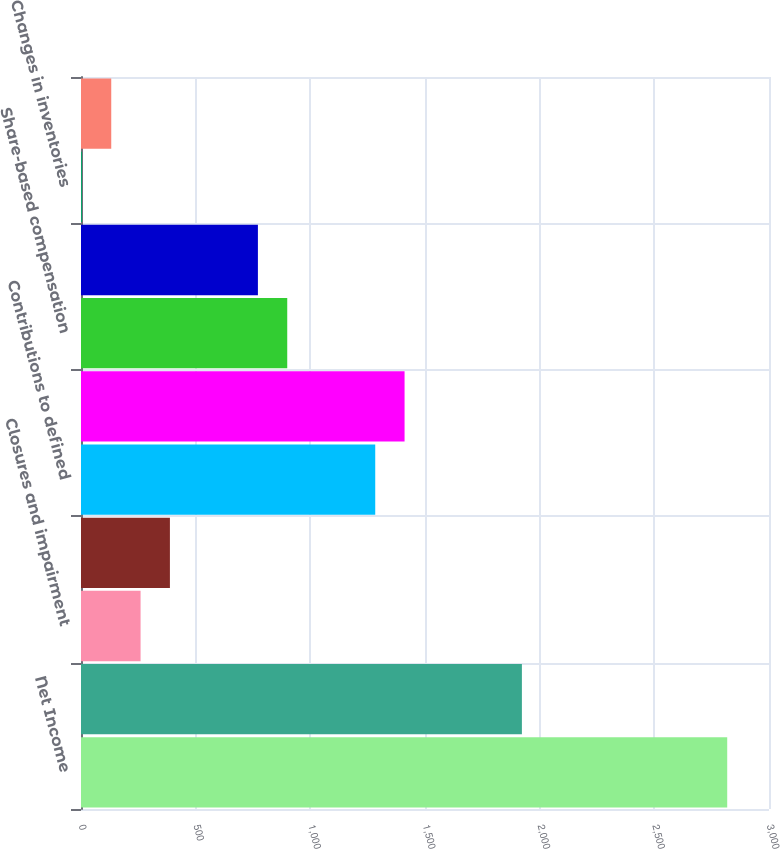<chart> <loc_0><loc_0><loc_500><loc_500><bar_chart><fcel>Net Income<fcel>Depreciation and amortization<fcel>Closures and impairment<fcel>Refranchising (gain) loss<fcel>Contributions to defined<fcel>Deferred income taxes<fcel>Share-based compensation<fcel>Changes in accounts and notes<fcel>Changes in inventories<fcel>Changes in prepaid expenses<nl><fcel>2817.8<fcel>1922.5<fcel>259.8<fcel>387.7<fcel>1283<fcel>1410.9<fcel>899.3<fcel>771.4<fcel>4<fcel>131.9<nl></chart> 